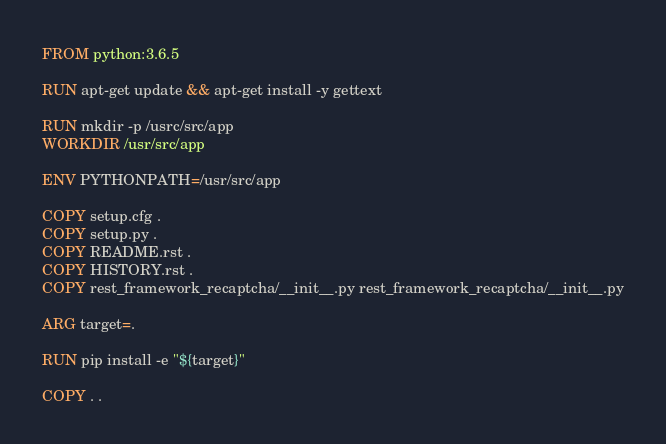<code> <loc_0><loc_0><loc_500><loc_500><_Dockerfile_>FROM python:3.6.5

RUN apt-get update && apt-get install -y gettext

RUN mkdir -p /usrc/src/app
WORKDIR /usr/src/app

ENV PYTHONPATH=/usr/src/app

COPY setup.cfg .
COPY setup.py .
COPY README.rst .
COPY HISTORY.rst .
COPY rest_framework_recaptcha/__init__.py rest_framework_recaptcha/__init__.py

ARG target=.

RUN pip install -e "${target}"

COPY . .
</code> 